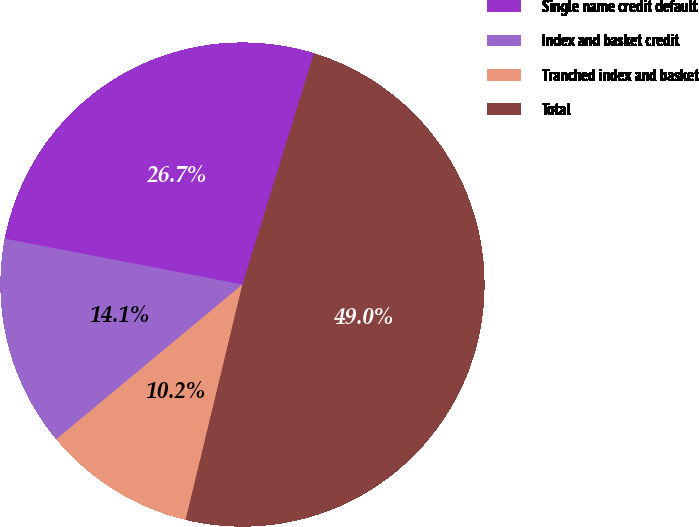Convert chart. <chart><loc_0><loc_0><loc_500><loc_500><pie_chart><fcel>Single name credit default<fcel>Index and basket credit<fcel>Tranched index and basket<fcel>Total<nl><fcel>26.74%<fcel>14.07%<fcel>10.19%<fcel>48.99%<nl></chart> 